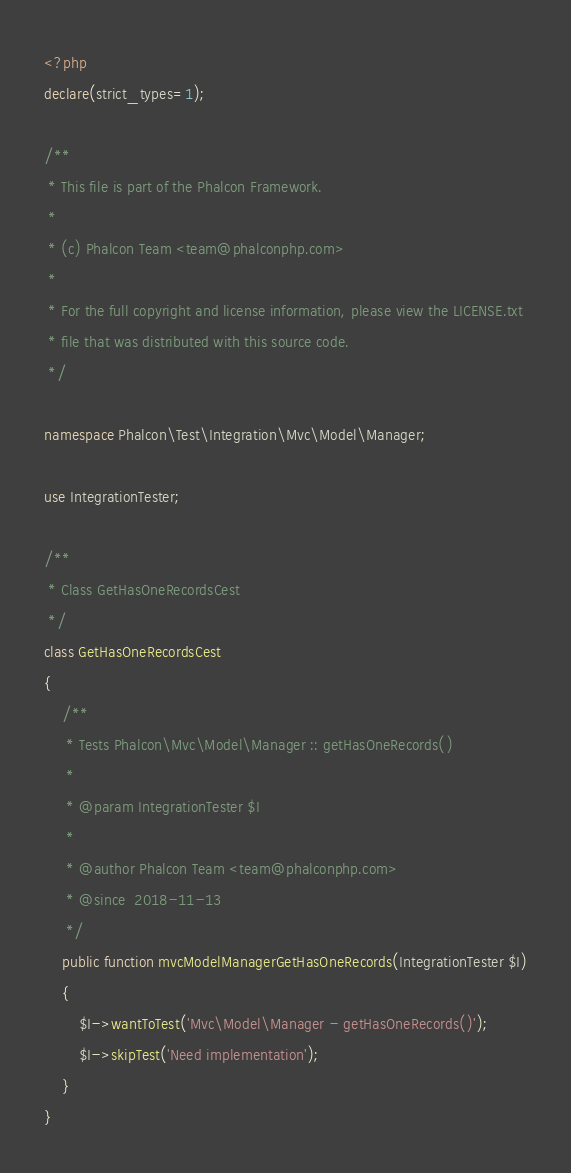Convert code to text. <code><loc_0><loc_0><loc_500><loc_500><_PHP_><?php
declare(strict_types=1);

/**
 * This file is part of the Phalcon Framework.
 *
 * (c) Phalcon Team <team@phalconphp.com>
 *
 * For the full copyright and license information, please view the LICENSE.txt
 * file that was distributed with this source code.
 */

namespace Phalcon\Test\Integration\Mvc\Model\Manager;

use IntegrationTester;

/**
 * Class GetHasOneRecordsCest
 */
class GetHasOneRecordsCest
{
    /**
     * Tests Phalcon\Mvc\Model\Manager :: getHasOneRecords()
     *
     * @param IntegrationTester $I
     *
     * @author Phalcon Team <team@phalconphp.com>
     * @since  2018-11-13
     */
    public function mvcModelManagerGetHasOneRecords(IntegrationTester $I)
    {
        $I->wantToTest('Mvc\Model\Manager - getHasOneRecords()');
        $I->skipTest('Need implementation');
    }
}
</code> 